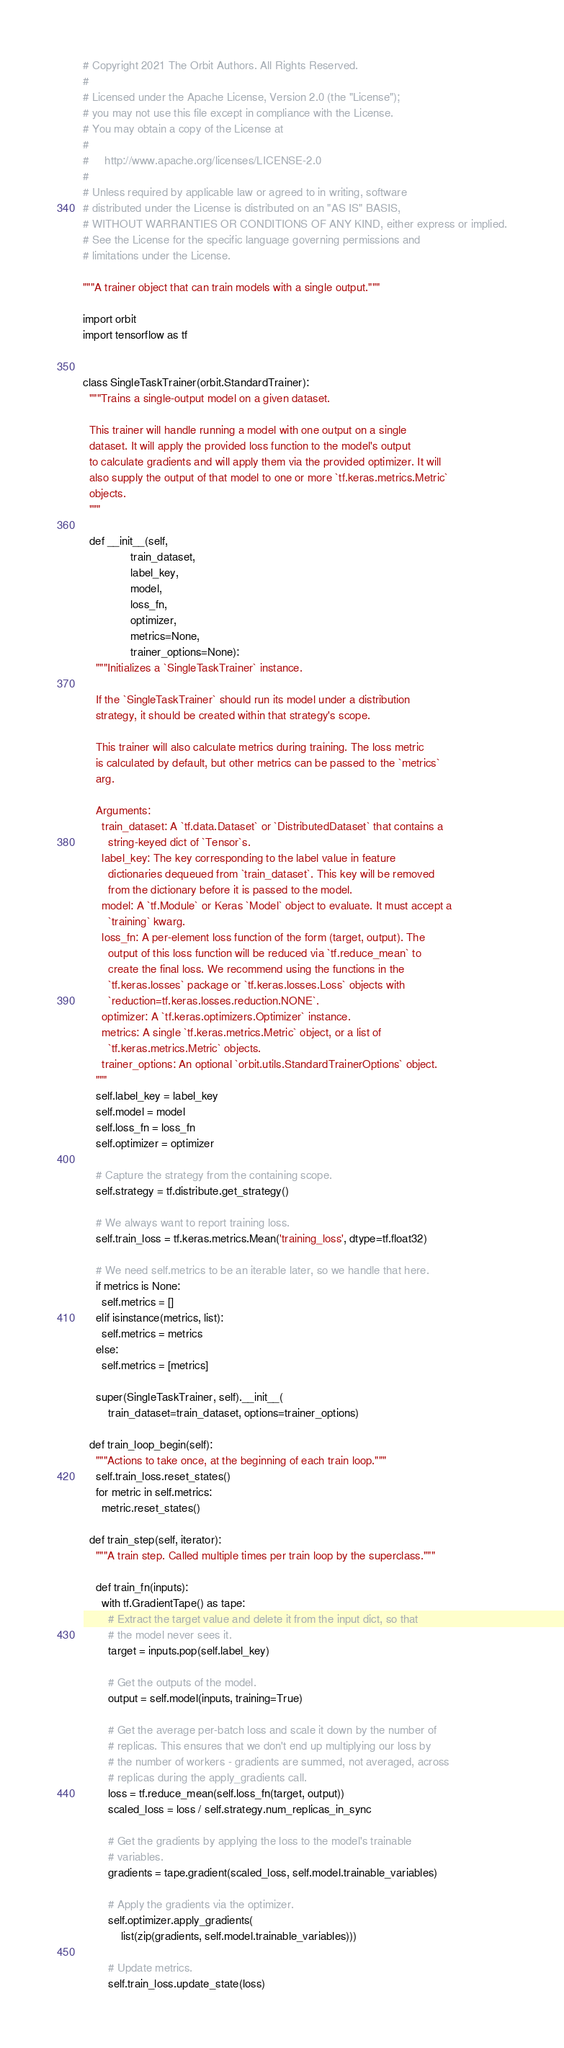<code> <loc_0><loc_0><loc_500><loc_500><_Python_># Copyright 2021 The Orbit Authors. All Rights Reserved.
#
# Licensed under the Apache License, Version 2.0 (the "License");
# you may not use this file except in compliance with the License.
# You may obtain a copy of the License at
#
#     http://www.apache.org/licenses/LICENSE-2.0
#
# Unless required by applicable law or agreed to in writing, software
# distributed under the License is distributed on an "AS IS" BASIS,
# WITHOUT WARRANTIES OR CONDITIONS OF ANY KIND, either express or implied.
# See the License for the specific language governing permissions and
# limitations under the License.

"""A trainer object that can train models with a single output."""

import orbit
import tensorflow as tf


class SingleTaskTrainer(orbit.StandardTrainer):
  """Trains a single-output model on a given dataset.

  This trainer will handle running a model with one output on a single
  dataset. It will apply the provided loss function to the model's output
  to calculate gradients and will apply them via the provided optimizer. It will
  also supply the output of that model to one or more `tf.keras.metrics.Metric`
  objects.
  """

  def __init__(self,
               train_dataset,
               label_key,
               model,
               loss_fn,
               optimizer,
               metrics=None,
               trainer_options=None):
    """Initializes a `SingleTaskTrainer` instance.

    If the `SingleTaskTrainer` should run its model under a distribution
    strategy, it should be created within that strategy's scope.

    This trainer will also calculate metrics during training. The loss metric
    is calculated by default, but other metrics can be passed to the `metrics`
    arg.

    Arguments:
      train_dataset: A `tf.data.Dataset` or `DistributedDataset` that contains a
        string-keyed dict of `Tensor`s.
      label_key: The key corresponding to the label value in feature
        dictionaries dequeued from `train_dataset`. This key will be removed
        from the dictionary before it is passed to the model.
      model: A `tf.Module` or Keras `Model` object to evaluate. It must accept a
        `training` kwarg.
      loss_fn: A per-element loss function of the form (target, output). The
        output of this loss function will be reduced via `tf.reduce_mean` to
        create the final loss. We recommend using the functions in the
        `tf.keras.losses` package or `tf.keras.losses.Loss` objects with
        `reduction=tf.keras.losses.reduction.NONE`.
      optimizer: A `tf.keras.optimizers.Optimizer` instance.
      metrics: A single `tf.keras.metrics.Metric` object, or a list of
        `tf.keras.metrics.Metric` objects.
      trainer_options: An optional `orbit.utils.StandardTrainerOptions` object.
    """
    self.label_key = label_key
    self.model = model
    self.loss_fn = loss_fn
    self.optimizer = optimizer

    # Capture the strategy from the containing scope.
    self.strategy = tf.distribute.get_strategy()

    # We always want to report training loss.
    self.train_loss = tf.keras.metrics.Mean('training_loss', dtype=tf.float32)

    # We need self.metrics to be an iterable later, so we handle that here.
    if metrics is None:
      self.metrics = []
    elif isinstance(metrics, list):
      self.metrics = metrics
    else:
      self.metrics = [metrics]

    super(SingleTaskTrainer, self).__init__(
        train_dataset=train_dataset, options=trainer_options)

  def train_loop_begin(self):
    """Actions to take once, at the beginning of each train loop."""
    self.train_loss.reset_states()
    for metric in self.metrics:
      metric.reset_states()

  def train_step(self, iterator):
    """A train step. Called multiple times per train loop by the superclass."""

    def train_fn(inputs):
      with tf.GradientTape() as tape:
        # Extract the target value and delete it from the input dict, so that
        # the model never sees it.
        target = inputs.pop(self.label_key)

        # Get the outputs of the model.
        output = self.model(inputs, training=True)

        # Get the average per-batch loss and scale it down by the number of
        # replicas. This ensures that we don't end up multiplying our loss by
        # the number of workers - gradients are summed, not averaged, across
        # replicas during the apply_gradients call.
        loss = tf.reduce_mean(self.loss_fn(target, output))
        scaled_loss = loss / self.strategy.num_replicas_in_sync

        # Get the gradients by applying the loss to the model's trainable
        # variables.
        gradients = tape.gradient(scaled_loss, self.model.trainable_variables)

        # Apply the gradients via the optimizer.
        self.optimizer.apply_gradients(
            list(zip(gradients, self.model.trainable_variables)))

        # Update metrics.
        self.train_loss.update_state(loss)</code> 